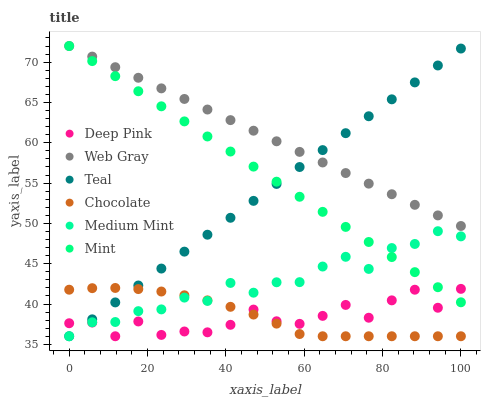Does Deep Pink have the minimum area under the curve?
Answer yes or no. Yes. Does Web Gray have the maximum area under the curve?
Answer yes or no. Yes. Does Chocolate have the minimum area under the curve?
Answer yes or no. No. Does Chocolate have the maximum area under the curve?
Answer yes or no. No. Is Web Gray the smoothest?
Answer yes or no. Yes. Is Deep Pink the roughest?
Answer yes or no. Yes. Is Chocolate the smoothest?
Answer yes or no. No. Is Chocolate the roughest?
Answer yes or no. No. Does Medium Mint have the lowest value?
Answer yes or no. Yes. Does Web Gray have the lowest value?
Answer yes or no. No. Does Mint have the highest value?
Answer yes or no. Yes. Does Chocolate have the highest value?
Answer yes or no. No. Is Chocolate less than Web Gray?
Answer yes or no. Yes. Is Web Gray greater than Medium Mint?
Answer yes or no. Yes. Does Mint intersect Deep Pink?
Answer yes or no. Yes. Is Mint less than Deep Pink?
Answer yes or no. No. Is Mint greater than Deep Pink?
Answer yes or no. No. Does Chocolate intersect Web Gray?
Answer yes or no. No. 